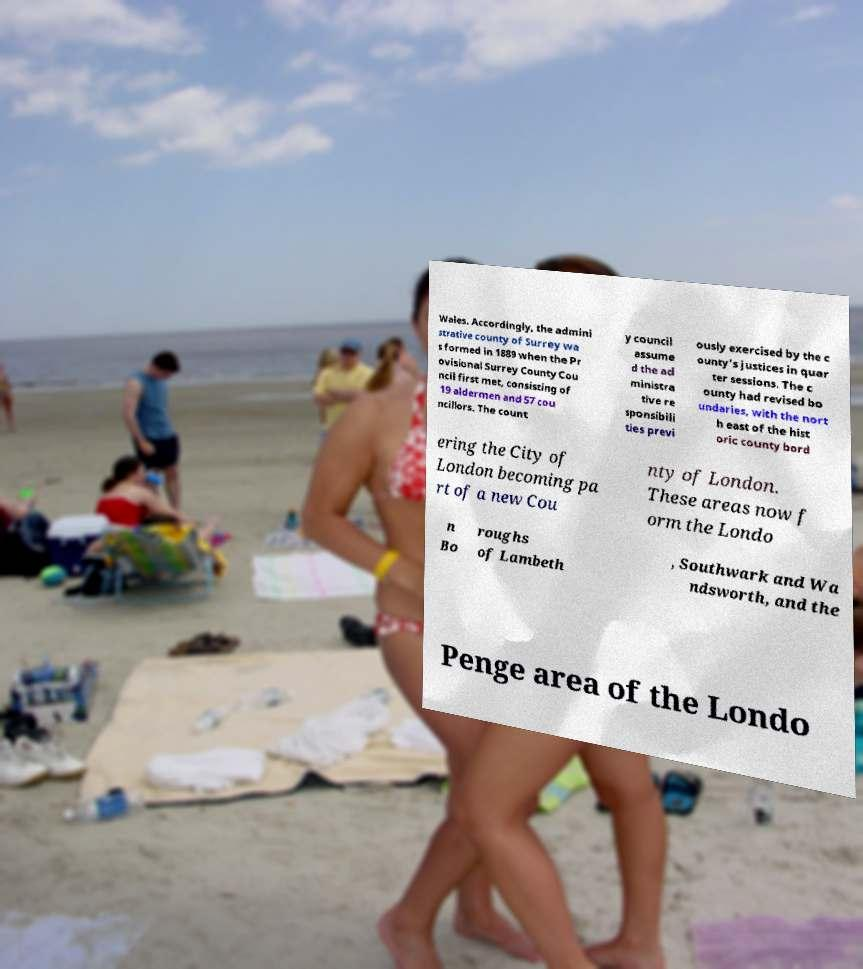Can you read and provide the text displayed in the image?This photo seems to have some interesting text. Can you extract and type it out for me? Wales. Accordingly, the admini strative county of Surrey wa s formed in 1889 when the Pr ovisional Surrey County Cou ncil first met, consisting of 19 aldermen and 57 cou ncillors. The count y council assume d the ad ministra tive re sponsibili ties previ ously exercised by the c ounty's justices in quar ter sessions. The c ounty had revised bo undaries, with the nort h east of the hist oric county bord ering the City of London becoming pa rt of a new Cou nty of London. These areas now f orm the Londo n Bo roughs of Lambeth , Southwark and Wa ndsworth, and the Penge area of the Londo 